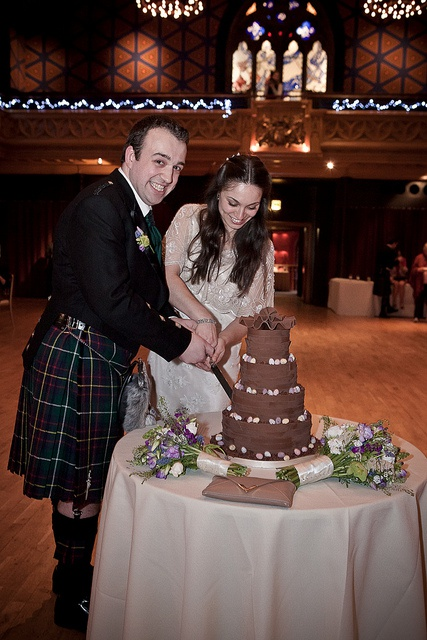Describe the objects in this image and their specific colors. I can see people in black, darkgray, gray, and maroon tones, people in black, darkgray, and gray tones, cake in black, maroon, and brown tones, handbag in black, gray, and brown tones, and people in black and maroon tones in this image. 